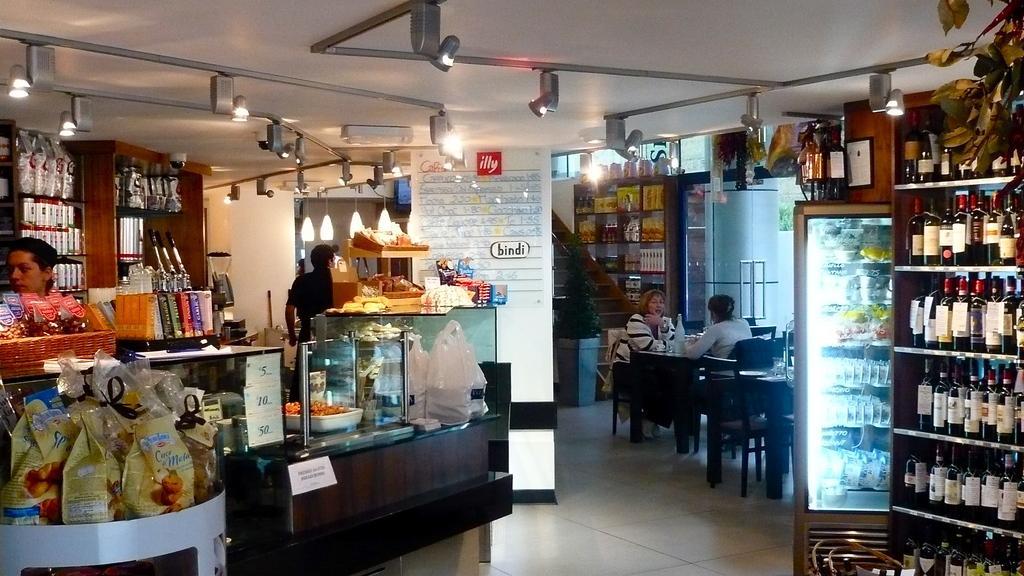How would you summarize this image in a sentence or two? In the image on the right side there is a cup board in that there are many bottles. In the right there is a refrigerator. In the middle there is a table in front of table there are two women sitting on the chairs. I think this is a shop. On the left there is a person. In the middle there is a wall. In the top there are many lights. On the left there are many food items. 